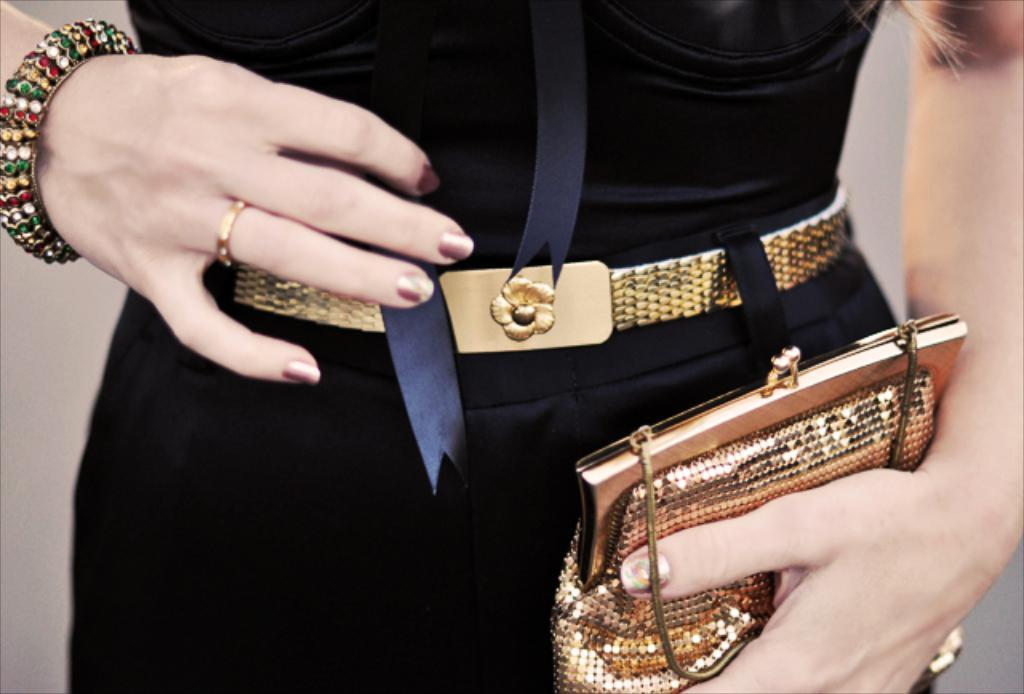What is the main subject of the image? The main subject of the image is a woman. What accessory is the woman wearing? The woman is wearing a bangle. What object is the woman holding in her hands? The woman is holding a purse in her hands. What news is the woman discussing with the expert in the image? There is no expert or news present in the image; it only features a woman wearing a bangle and holding a purse. 